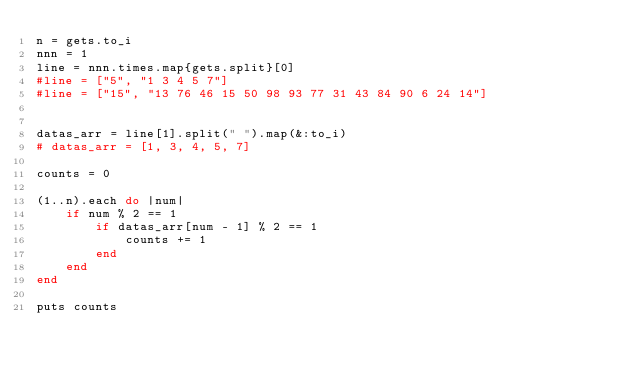<code> <loc_0><loc_0><loc_500><loc_500><_Ruby_>n = gets.to_i
nnn = 1
line = nnn.times.map{gets.split}[0]
#line = ["5", "1 3 4 5 7"]
#line = ["15", "13 76 46 15 50 98 93 77 31 43 84 90 6 24 14"]


datas_arr = line[1].split(" ").map(&:to_i)
# datas_arr = [1, 3, 4, 5, 7]

counts = 0

(1..n).each do |num|
    if num % 2 == 1
        if datas_arr[num - 1] % 2 == 1
            counts += 1
        end
    end
end

puts counts</code> 